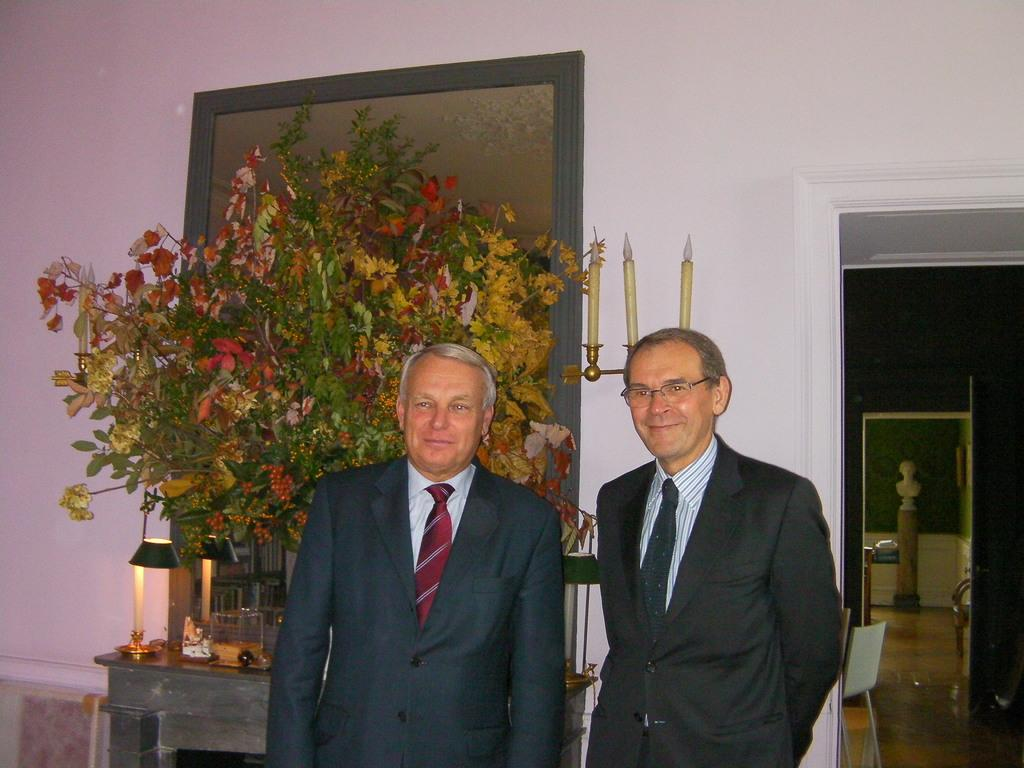What are the people in the image doing? The people in the image are standing. What type of clothing are the people wearing? The people are wearing formal suits. What can be seen on the table in the background? There are flowers on a table in the background. What is present on the wall in the background? There is a photo frame on the wall in the background. What type of rock can be seen in the image? There is no rock present in the image. 